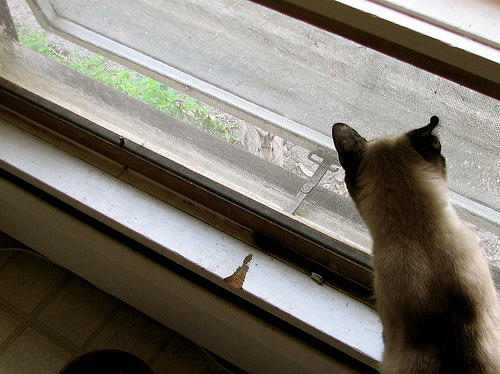<image>
Can you confirm if the cat is next to the rabbit? No. The cat is not positioned next to the rabbit. They are located in different areas of the scene. 